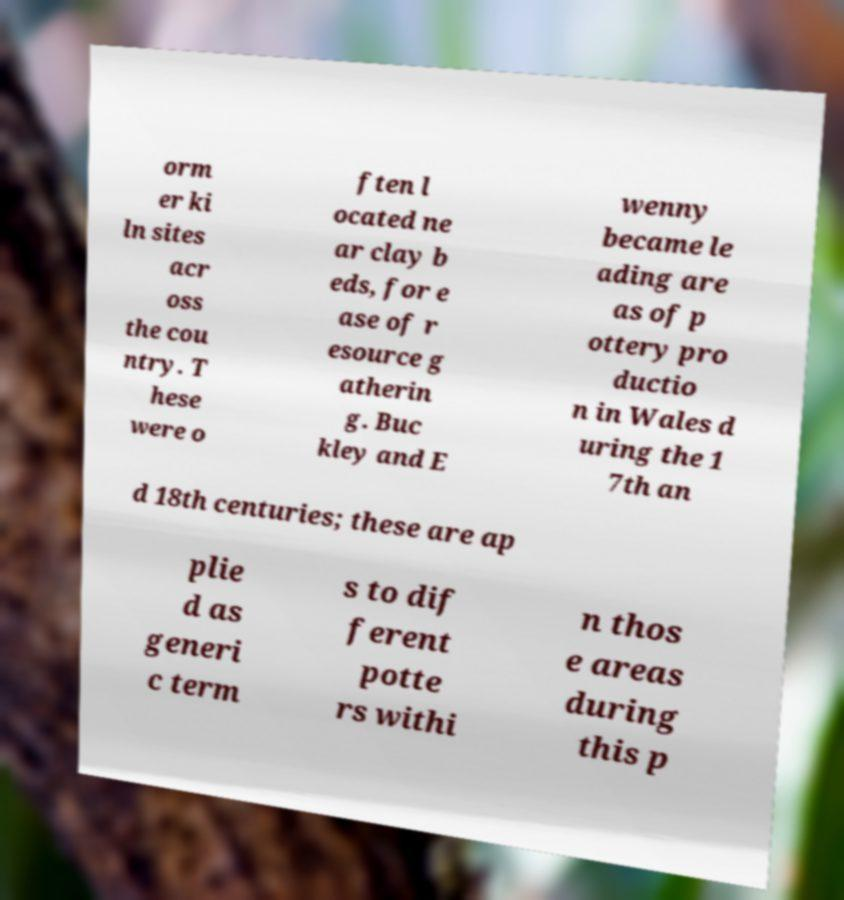Can you read and provide the text displayed in the image?This photo seems to have some interesting text. Can you extract and type it out for me? orm er ki ln sites acr oss the cou ntry. T hese were o ften l ocated ne ar clay b eds, for e ase of r esource g atherin g. Buc kley and E wenny became le ading are as of p ottery pro ductio n in Wales d uring the 1 7th an d 18th centuries; these are ap plie d as generi c term s to dif ferent potte rs withi n thos e areas during this p 